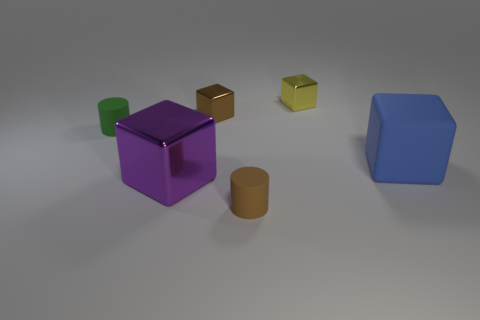Is the material of the big block on the left side of the brown cylinder the same as the object to the left of the big shiny object?
Offer a terse response. No. There is a small brown object that is the same shape as the big rubber thing; what material is it?
Offer a terse response. Metal. Is the material of the green cylinder the same as the blue object?
Your answer should be very brief. Yes. What color is the metallic cube that is in front of the brown object behind the blue rubber thing?
Your response must be concise. Purple. There is a purple block that is made of the same material as the brown block; what is its size?
Your response must be concise. Large. How many other purple objects are the same shape as the purple metallic object?
Provide a succinct answer. 0. How many objects are blocks that are to the right of the small yellow cube or things that are to the left of the yellow object?
Your answer should be compact. 5. There is a small metallic cube left of the yellow cube; what number of small rubber objects are on the left side of it?
Ensure brevity in your answer.  1. There is a brown object in front of the green cylinder; does it have the same shape as the shiny thing that is in front of the big rubber object?
Your answer should be very brief. No. Is there a big red cube that has the same material as the large purple thing?
Your answer should be very brief. No. 